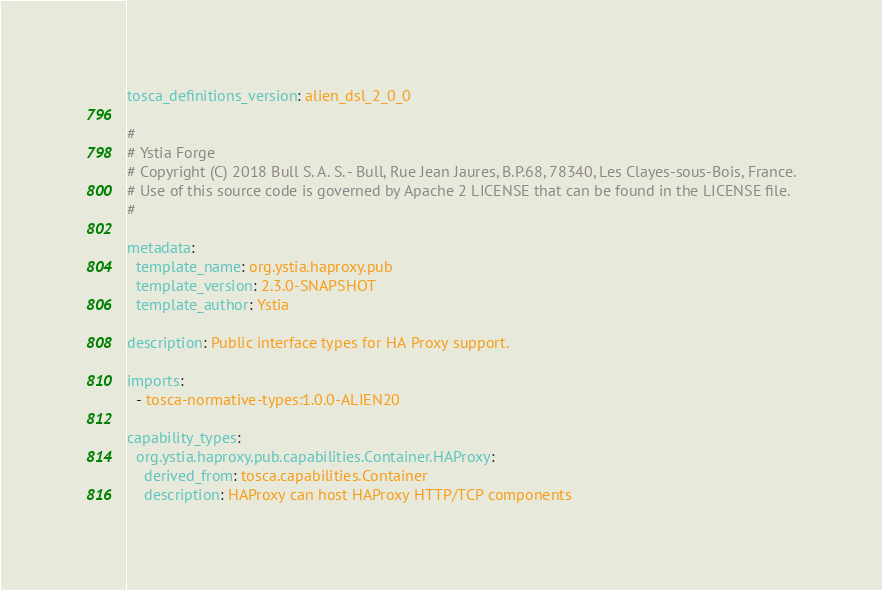<code> <loc_0><loc_0><loc_500><loc_500><_YAML_>tosca_definitions_version: alien_dsl_2_0_0

#
# Ystia Forge
# Copyright (C) 2018 Bull S. A. S. - Bull, Rue Jean Jaures, B.P.68, 78340, Les Clayes-sous-Bois, France.
# Use of this source code is governed by Apache 2 LICENSE that can be found in the LICENSE file.
#

metadata:
  template_name: org.ystia.haproxy.pub
  template_version: 2.3.0-SNAPSHOT
  template_author: Ystia

description: Public interface types for HA Proxy support.

imports:
  - tosca-normative-types:1.0.0-ALIEN20

capability_types:
  org.ystia.haproxy.pub.capabilities.Container.HAProxy:
    derived_from: tosca.capabilities.Container
    description: HAProxy can host HAProxy HTTP/TCP components</code> 